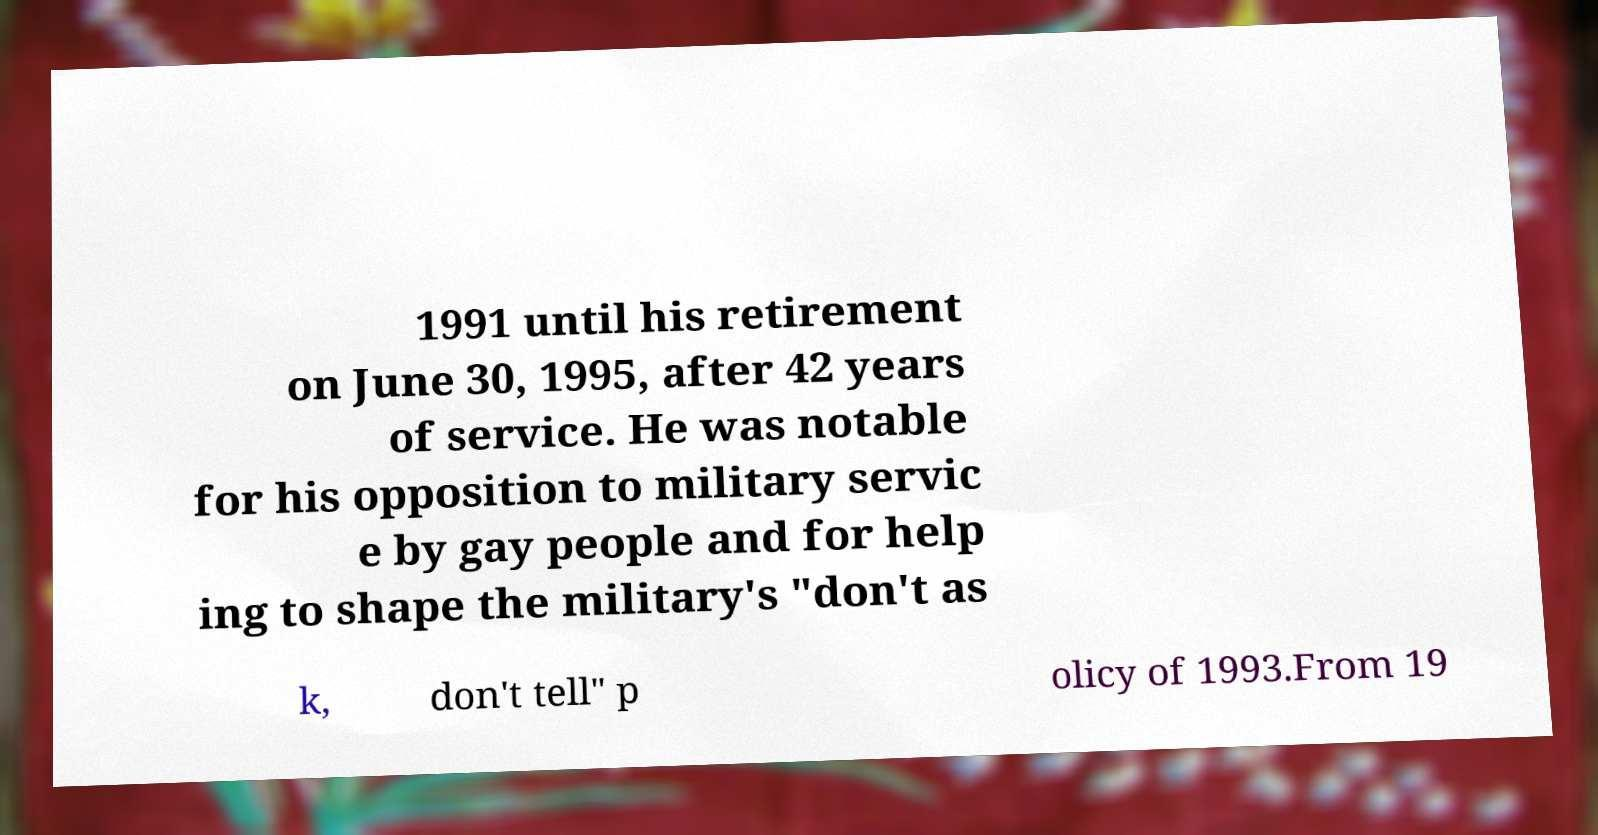I need the written content from this picture converted into text. Can you do that? 1991 until his retirement on June 30, 1995, after 42 years of service. He was notable for his opposition to military servic e by gay people and for help ing to shape the military's "don't as k, don't tell" p olicy of 1993.From 19 